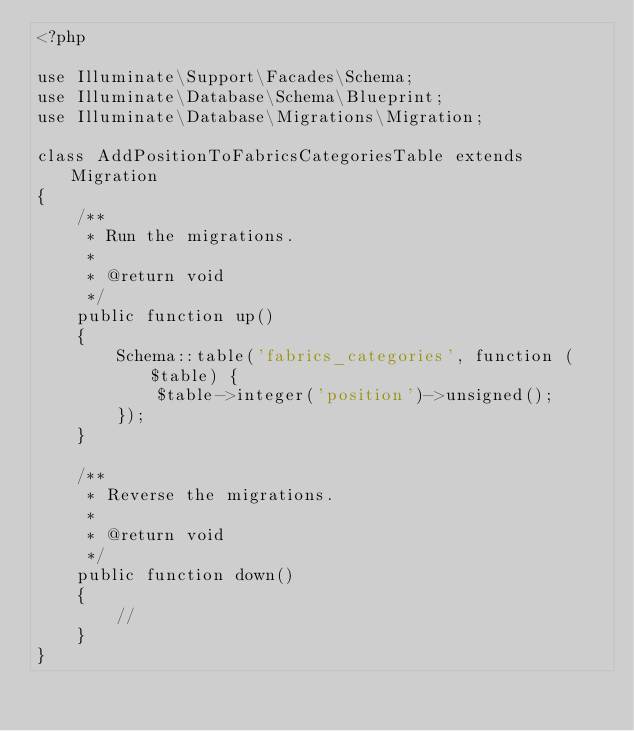Convert code to text. <code><loc_0><loc_0><loc_500><loc_500><_PHP_><?php

use Illuminate\Support\Facades\Schema;
use Illuminate\Database\Schema\Blueprint;
use Illuminate\Database\Migrations\Migration;

class AddPositionToFabricsCategoriesTable extends Migration
{
    /**
     * Run the migrations.
     *
     * @return void
     */
    public function up()
    {
        Schema::table('fabrics_categories', function ($table) {
            $table->integer('position')->unsigned();
        });
    }

    /**
     * Reverse the migrations.
     *
     * @return void
     */
    public function down()
    {
        //
    }
}
</code> 